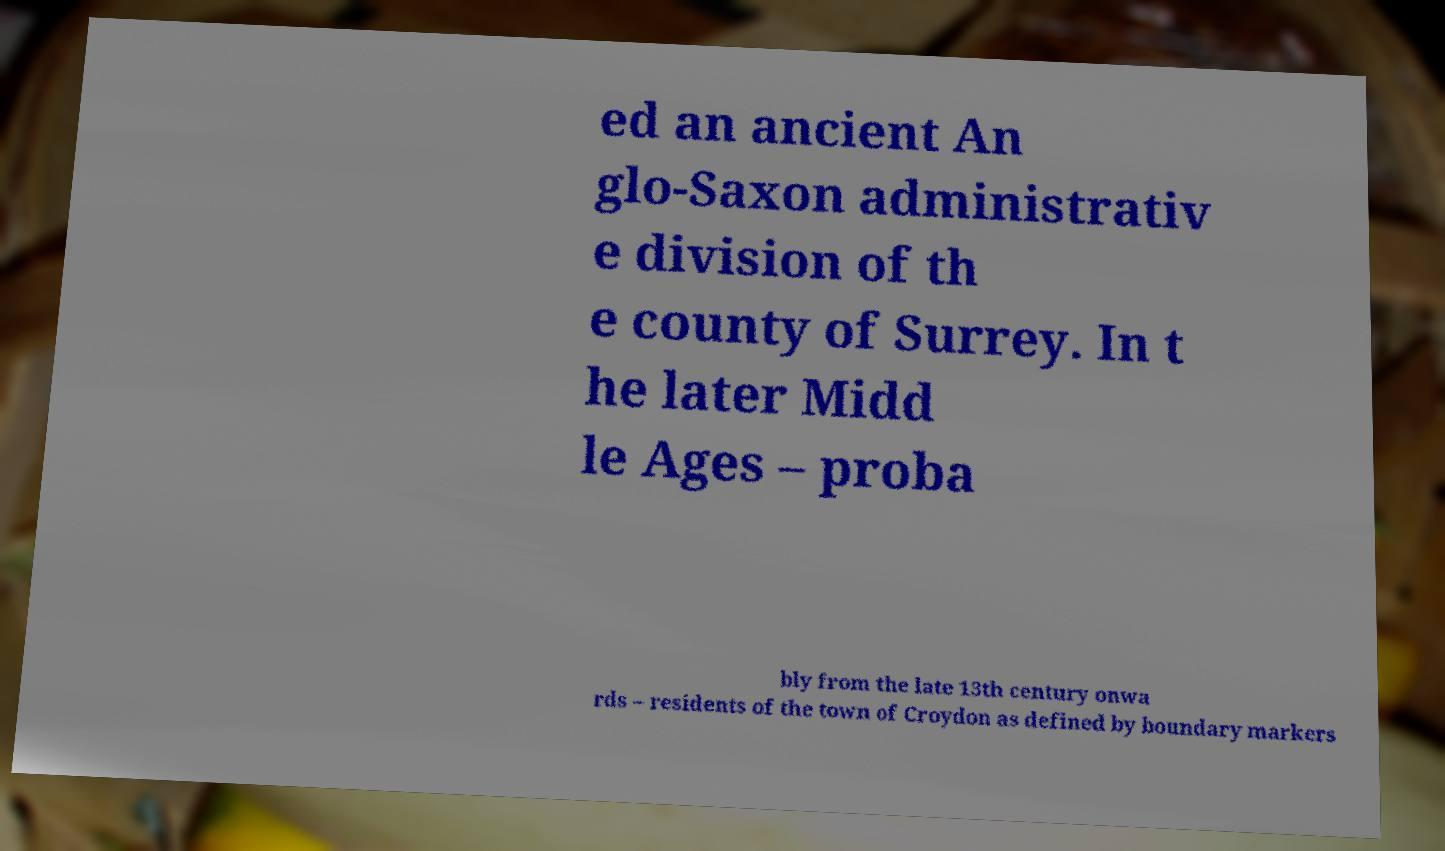Could you extract and type out the text from this image? ed an ancient An glo-Saxon administrativ e division of th e county of Surrey. In t he later Midd le Ages – proba bly from the late 13th century onwa rds – residents of the town of Croydon as defined by boundary markers 